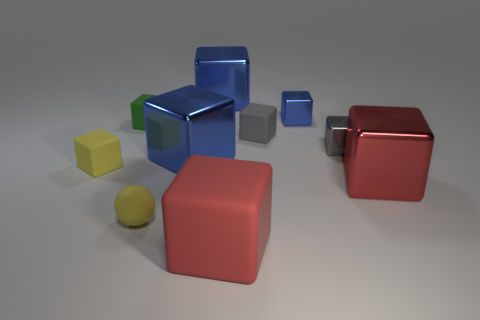How many blue blocks must be subtracted to get 1 blue blocks? 2 Subtract all red cylinders. How many blue blocks are left? 3 Subtract 3 cubes. How many cubes are left? 6 Subtract all yellow blocks. How many blocks are left? 8 Subtract all small yellow cubes. How many cubes are left? 8 Subtract all cyan cubes. Subtract all blue spheres. How many cubes are left? 9 Subtract all spheres. How many objects are left? 9 Add 9 yellow rubber balls. How many yellow rubber balls exist? 10 Subtract 0 yellow cylinders. How many objects are left? 10 Subtract all gray rubber things. Subtract all yellow balls. How many objects are left? 8 